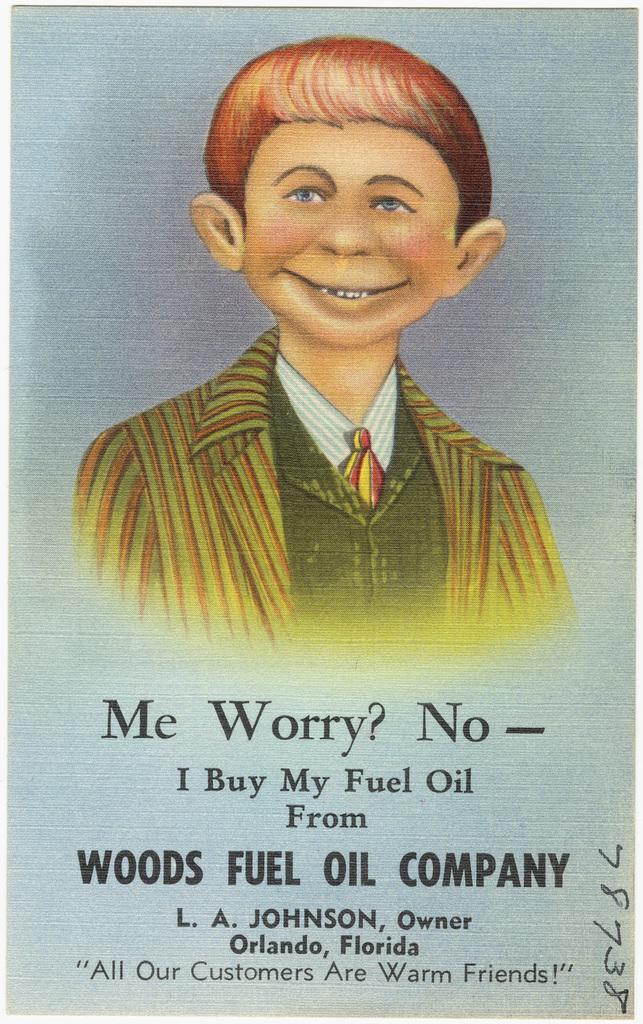Please provide a concise description of this image. In this image we can see an advertisement. At the top of the image we can see a person's picture. At the bottom of the image we can see the text. 